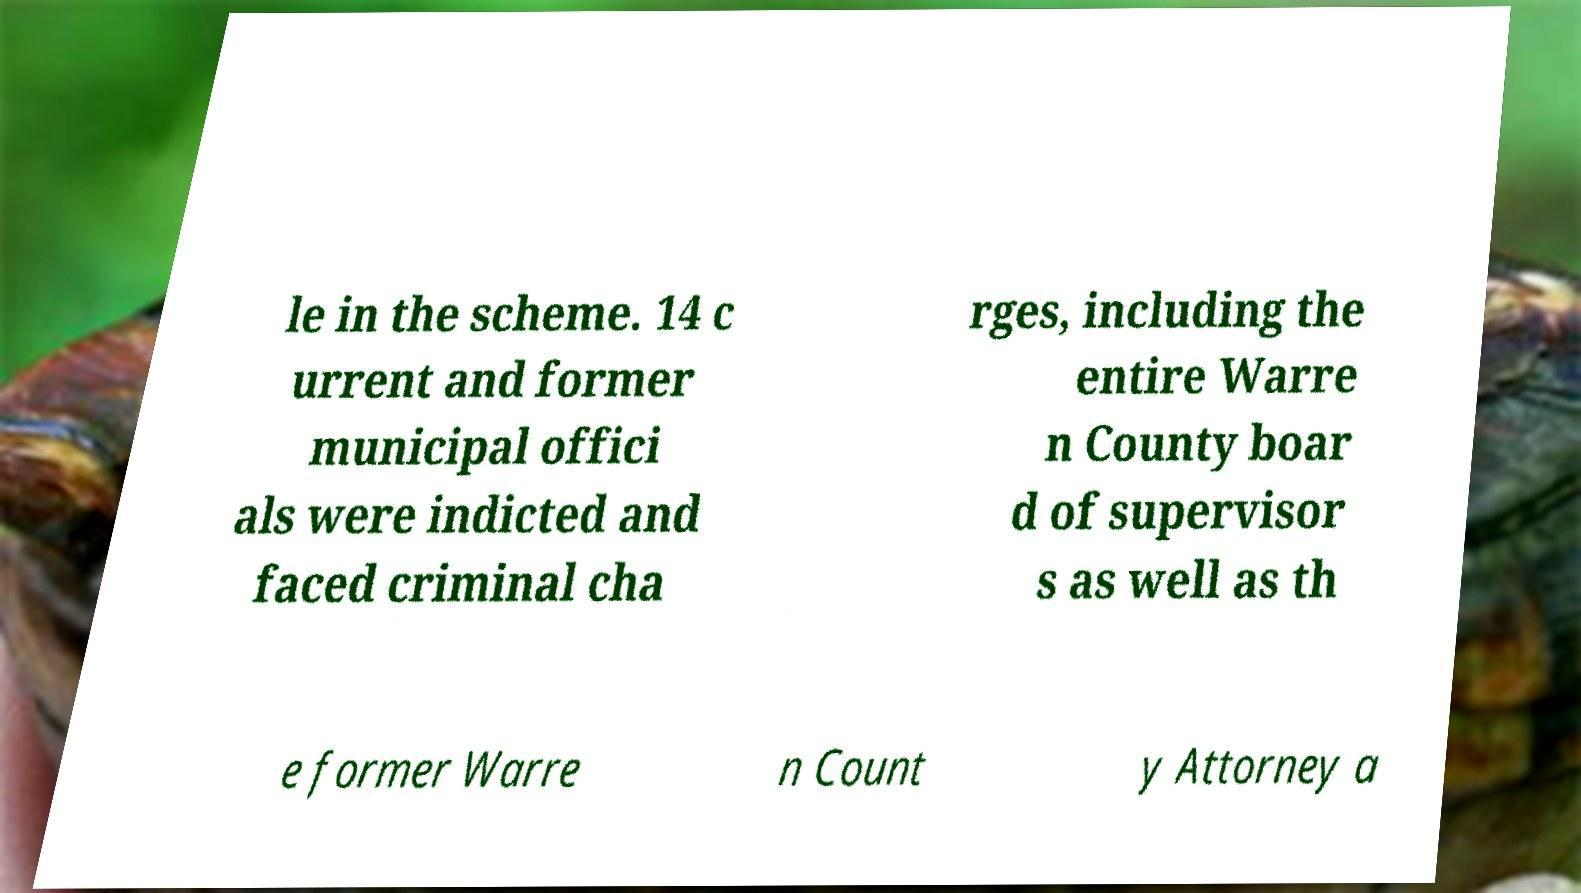Please read and relay the text visible in this image. What does it say? le in the scheme. 14 c urrent and former municipal offici als were indicted and faced criminal cha rges, including the entire Warre n County boar d of supervisor s as well as th e former Warre n Count y Attorney a 